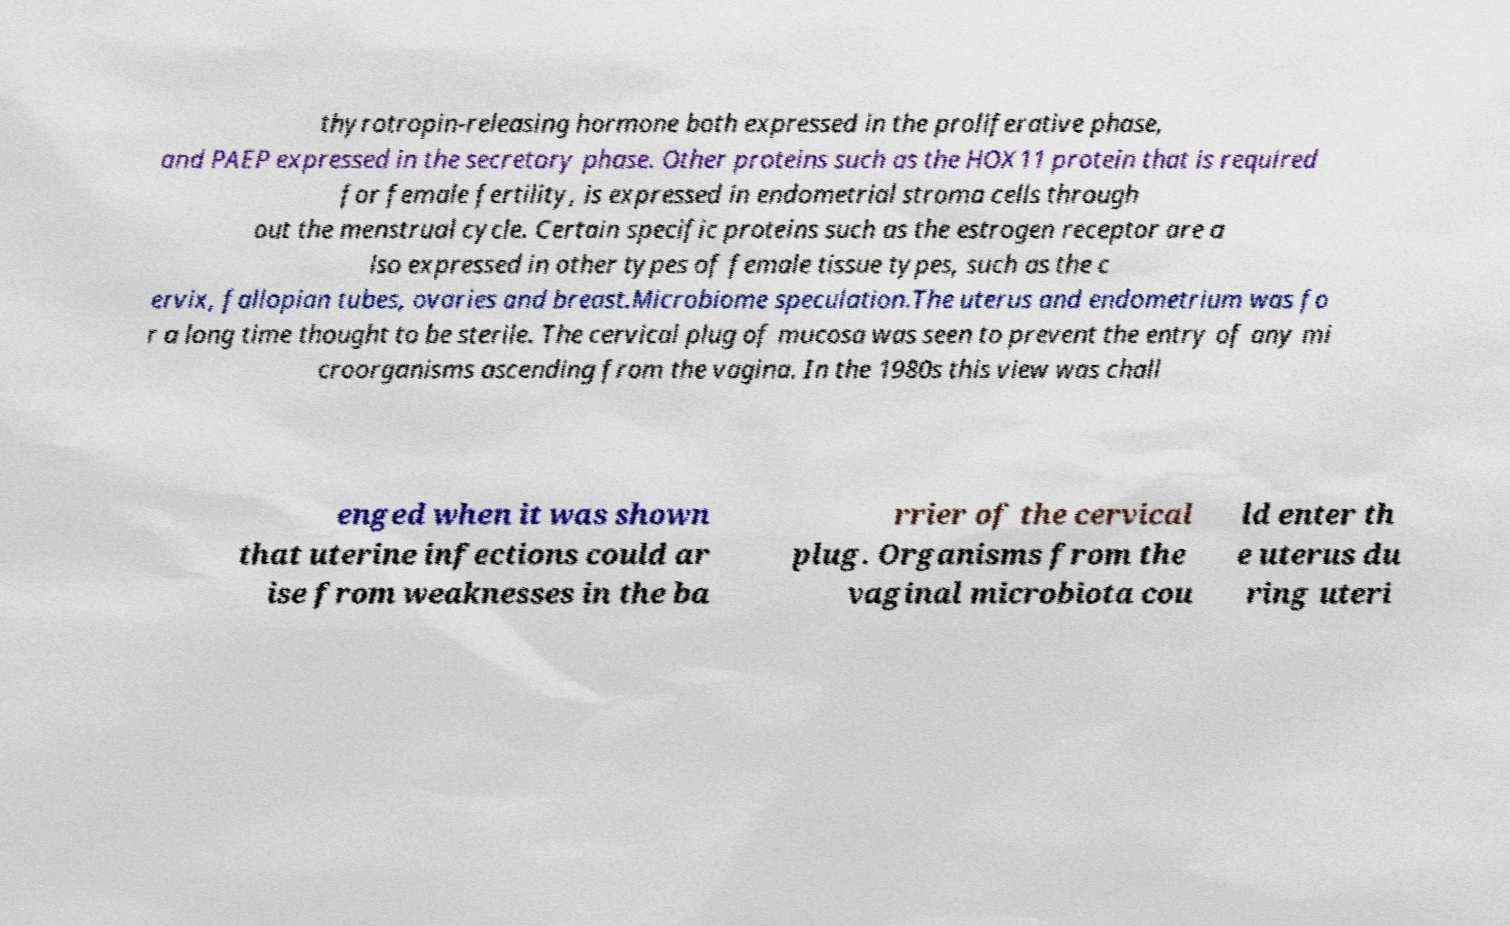For documentation purposes, I need the text within this image transcribed. Could you provide that? thyrotropin-releasing hormone both expressed in the proliferative phase, and PAEP expressed in the secretory phase. Other proteins such as the HOX11 protein that is required for female fertility, is expressed in endometrial stroma cells through out the menstrual cycle. Certain specific proteins such as the estrogen receptor are a lso expressed in other types of female tissue types, such as the c ervix, fallopian tubes, ovaries and breast.Microbiome speculation.The uterus and endometrium was fo r a long time thought to be sterile. The cervical plug of mucosa was seen to prevent the entry of any mi croorganisms ascending from the vagina. In the 1980s this view was chall enged when it was shown that uterine infections could ar ise from weaknesses in the ba rrier of the cervical plug. Organisms from the vaginal microbiota cou ld enter th e uterus du ring uteri 